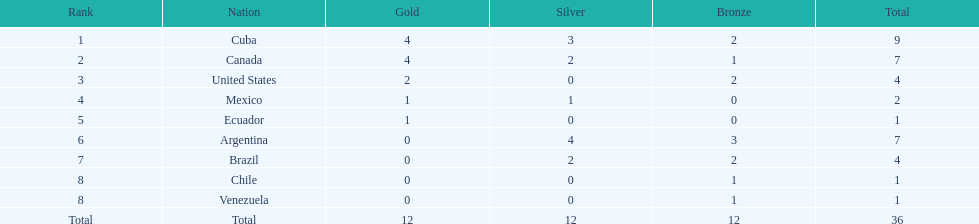Which country obtained the highest collection of bronze medals? Argentina. 